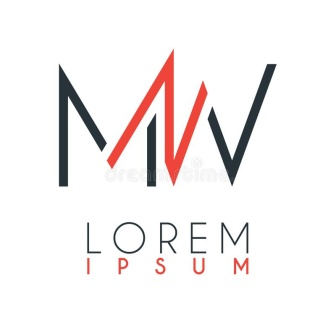Write a detailed description of the given image.
 The image presents a striking logo design for a company named "Lorem Ipsum". Dominating the design is a stylized letter "M", rendered in a bold black color. Perched atop the "M" is a letter "W", depicted in a vibrant shade of red. The interplay between the "M" and "W" creates a dynamic visual effect, suggesting a sense of unity or partnership. 

Beneath this intriguing combination of letters, the company's name, "Lorem Ipsum", is prominently displayed. The text mirrors the color scheme of the logo, with "Lorem" in black and "Ipsum" in red, reinforcing the brand identity. The overall design is simple yet effective, with the contrasting colors and stylized letters making a memorable impression. 